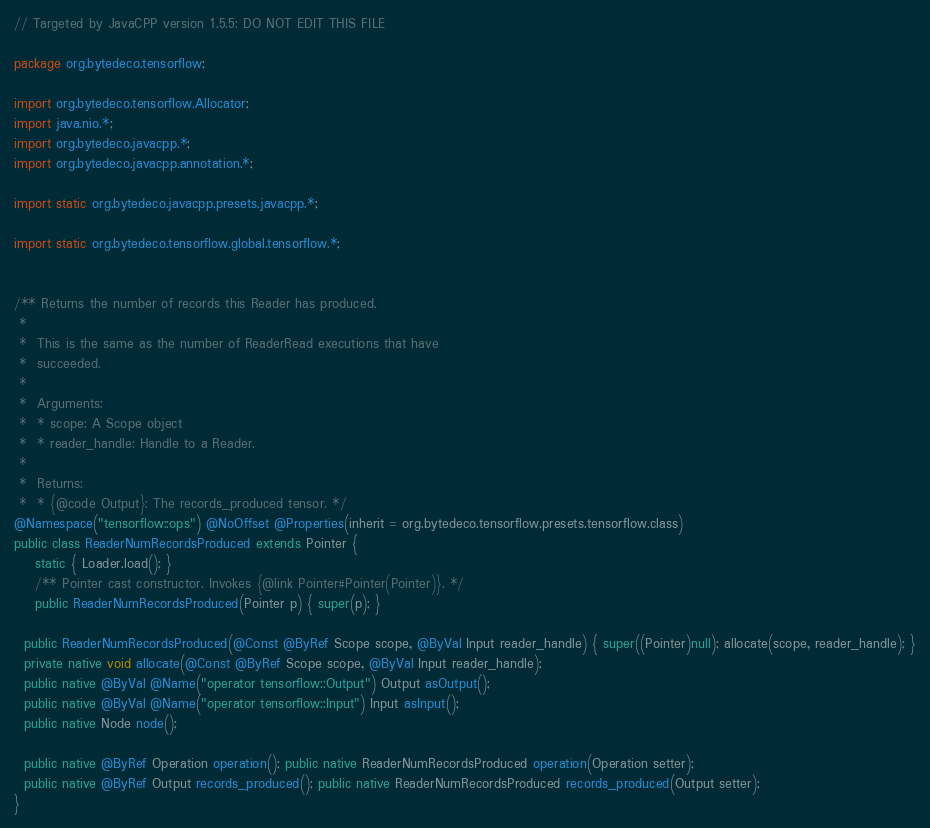Convert code to text. <code><loc_0><loc_0><loc_500><loc_500><_Java_>// Targeted by JavaCPP version 1.5.5: DO NOT EDIT THIS FILE

package org.bytedeco.tensorflow;

import org.bytedeco.tensorflow.Allocator;
import java.nio.*;
import org.bytedeco.javacpp.*;
import org.bytedeco.javacpp.annotation.*;

import static org.bytedeco.javacpp.presets.javacpp.*;

import static org.bytedeco.tensorflow.global.tensorflow.*;


/** Returns the number of records this Reader has produced.
 * 
 *  This is the same as the number of ReaderRead executions that have
 *  succeeded.
 * 
 *  Arguments:
 *  * scope: A Scope object
 *  * reader_handle: Handle to a Reader.
 * 
 *  Returns:
 *  * {@code Output}: The records_produced tensor. */
@Namespace("tensorflow::ops") @NoOffset @Properties(inherit = org.bytedeco.tensorflow.presets.tensorflow.class)
public class ReaderNumRecordsProduced extends Pointer {
    static { Loader.load(); }
    /** Pointer cast constructor. Invokes {@link Pointer#Pointer(Pointer)}. */
    public ReaderNumRecordsProduced(Pointer p) { super(p); }

  public ReaderNumRecordsProduced(@Const @ByRef Scope scope, @ByVal Input reader_handle) { super((Pointer)null); allocate(scope, reader_handle); }
  private native void allocate(@Const @ByRef Scope scope, @ByVal Input reader_handle);
  public native @ByVal @Name("operator tensorflow::Output") Output asOutput();
  public native @ByVal @Name("operator tensorflow::Input") Input asInput();
  public native Node node();

  public native @ByRef Operation operation(); public native ReaderNumRecordsProduced operation(Operation setter);
  public native @ByRef Output records_produced(); public native ReaderNumRecordsProduced records_produced(Output setter);
}
</code> 